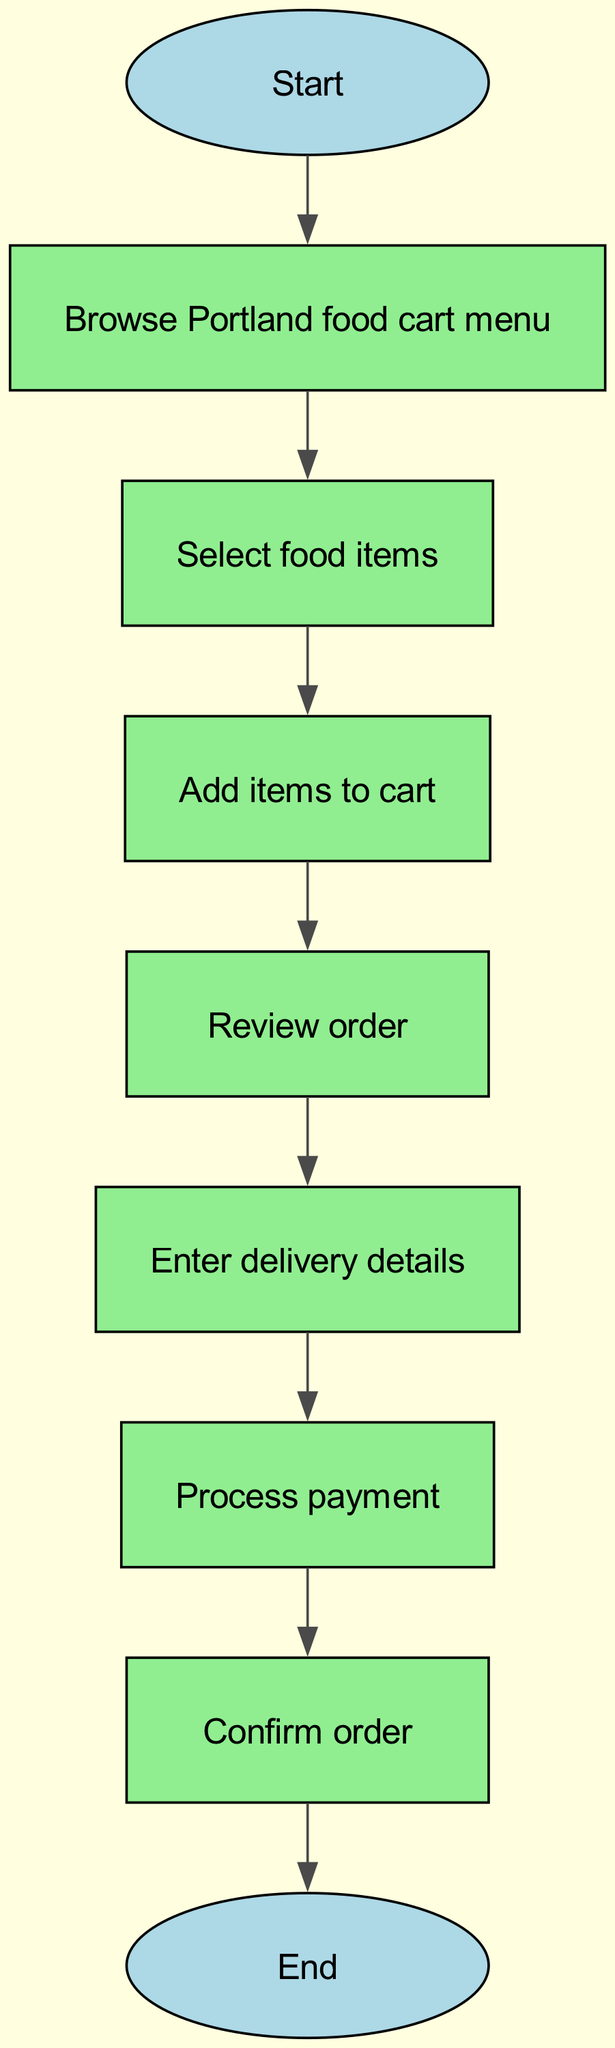What is the first action in the flowchart? The first action in the flowchart is represented by the 'start' node, which leads to browsing the menu. Hence, the action that occurs first is "Browse Portland food cart menu."
Answer: Browse Portland food cart menu How many nodes are in the flowchart? By counting each unique node listed, we find there are 9 nodes: Start, Browse Portland food cart menu, Select food items, Add items to cart, Review order, Enter delivery details, Process payment, Confirm order, and End. Therefore, the total number of nodes is 9.
Answer: 9 What follows after selecting items? Following the 'select_items' node, the next node in the flowchart is 'add_to_cart', indicating that once items are selected, they need to be added to the cart.
Answer: Add items to cart What is the final step before reaching the end of the flowchart? The last action that occurs right before the flowchart concludes at the 'end' node is represented by the 'confirm_order' node, indicating that confirmation is the final step.
Answer: Confirm order Is payment processed before or after entering delivery details? According to the flowchart, 'enter_details' directly precedes 'payment', indicating that entering delivery details must occur before the payment processing step.
Answer: Before What types of actions can be classified as nodes in this flowchart? In the context of this flowchart, the actions can be classified into start, browsing the menu, selecting items, adding to cart, reviewing the order, entering details, processing payment, confirming the order, and ending the process.
Answer: Start, Browse menu, Select items, Add to cart, Review order, Enter details, Process payment, Confirm order, End How many edges connect the nodes in the flowchart? By examining the edges closely, we can see the connections drawn between each step. There are 8 edges, thereby connecting all nodes sequentially.
Answer: 8 What is the action taken after reviewing the order? After the action taken at the 'review_order' node, the next step requires the user to 'enter_details', as indicated by the transition from reviewing the order to entering delivery details.
Answer: Enter delivery details 